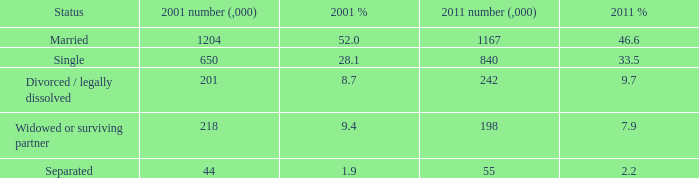9 as a percentage of 2011? 1.0. 